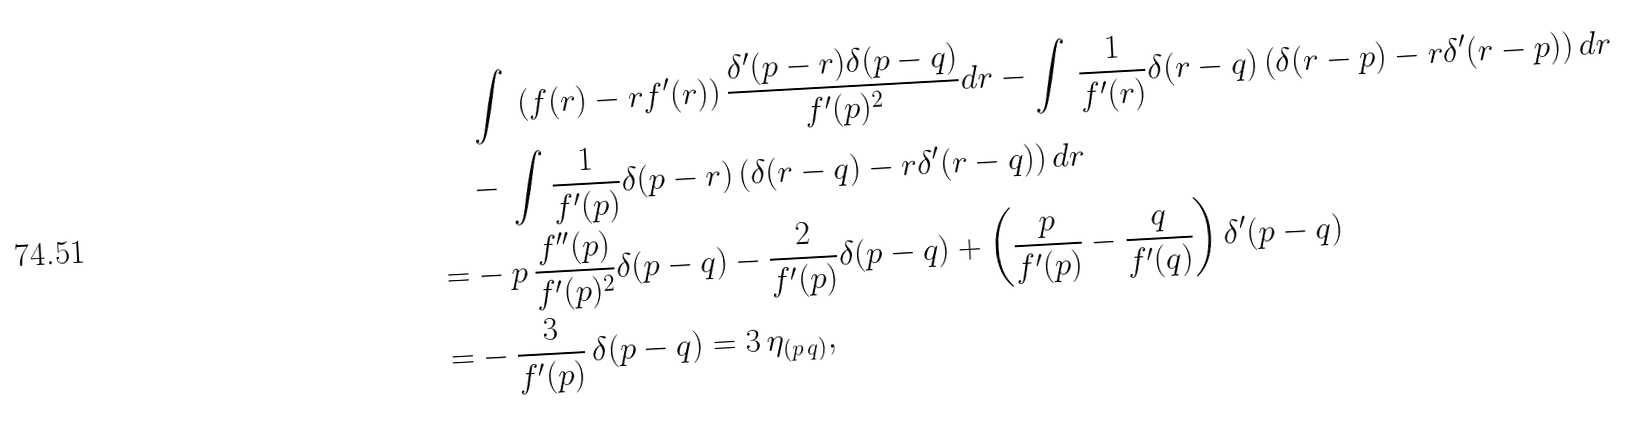Convert formula to latex. <formula><loc_0><loc_0><loc_500><loc_500>& \, \int \, \left ( f ( r ) - r f ^ { \prime } ( r ) \right ) \frac { \delta ^ { \prime } ( p - r ) \delta ( p - q ) } { f ^ { \prime } ( p ) ^ { 2 } } d r - \int \, \frac { 1 } { f ^ { \prime } ( r ) } \delta ( r - q ) \left ( \delta ( r - p ) - r \delta ^ { \prime } ( r - p ) \right ) d r \\ & - \, \int \frac { 1 } { f ^ { \prime } ( p ) } \delta ( p - r ) \left ( \delta ( r - q ) - r \delta ^ { \prime } ( r - q ) \right ) d r \\ = & - p \, \frac { f ^ { \prime \prime } ( p ) } { f ^ { \prime } ( p ) ^ { 2 } } \delta ( p - q ) - \frac { 2 } { f ^ { \prime } ( p ) } \delta ( p - q ) + \left ( \frac { p } { f ^ { \prime } ( p ) } - \frac { q } { f ^ { \prime } ( q ) } \right ) \delta ^ { \prime } ( p - q ) \\ = & - \frac { 3 } { f ^ { \prime } ( p ) } \, \delta ( p - q ) = 3 \, \eta _ { ( p \, q ) } ,</formula> 